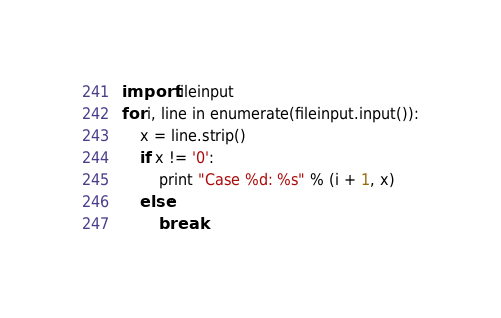<code> <loc_0><loc_0><loc_500><loc_500><_Python_>import fileinput
for i, line in enumerate(fileinput.input()):
    x = line.strip()
    if x != '0':
        print "Case %d: %s" % (i + 1, x)
    else:
        break</code> 